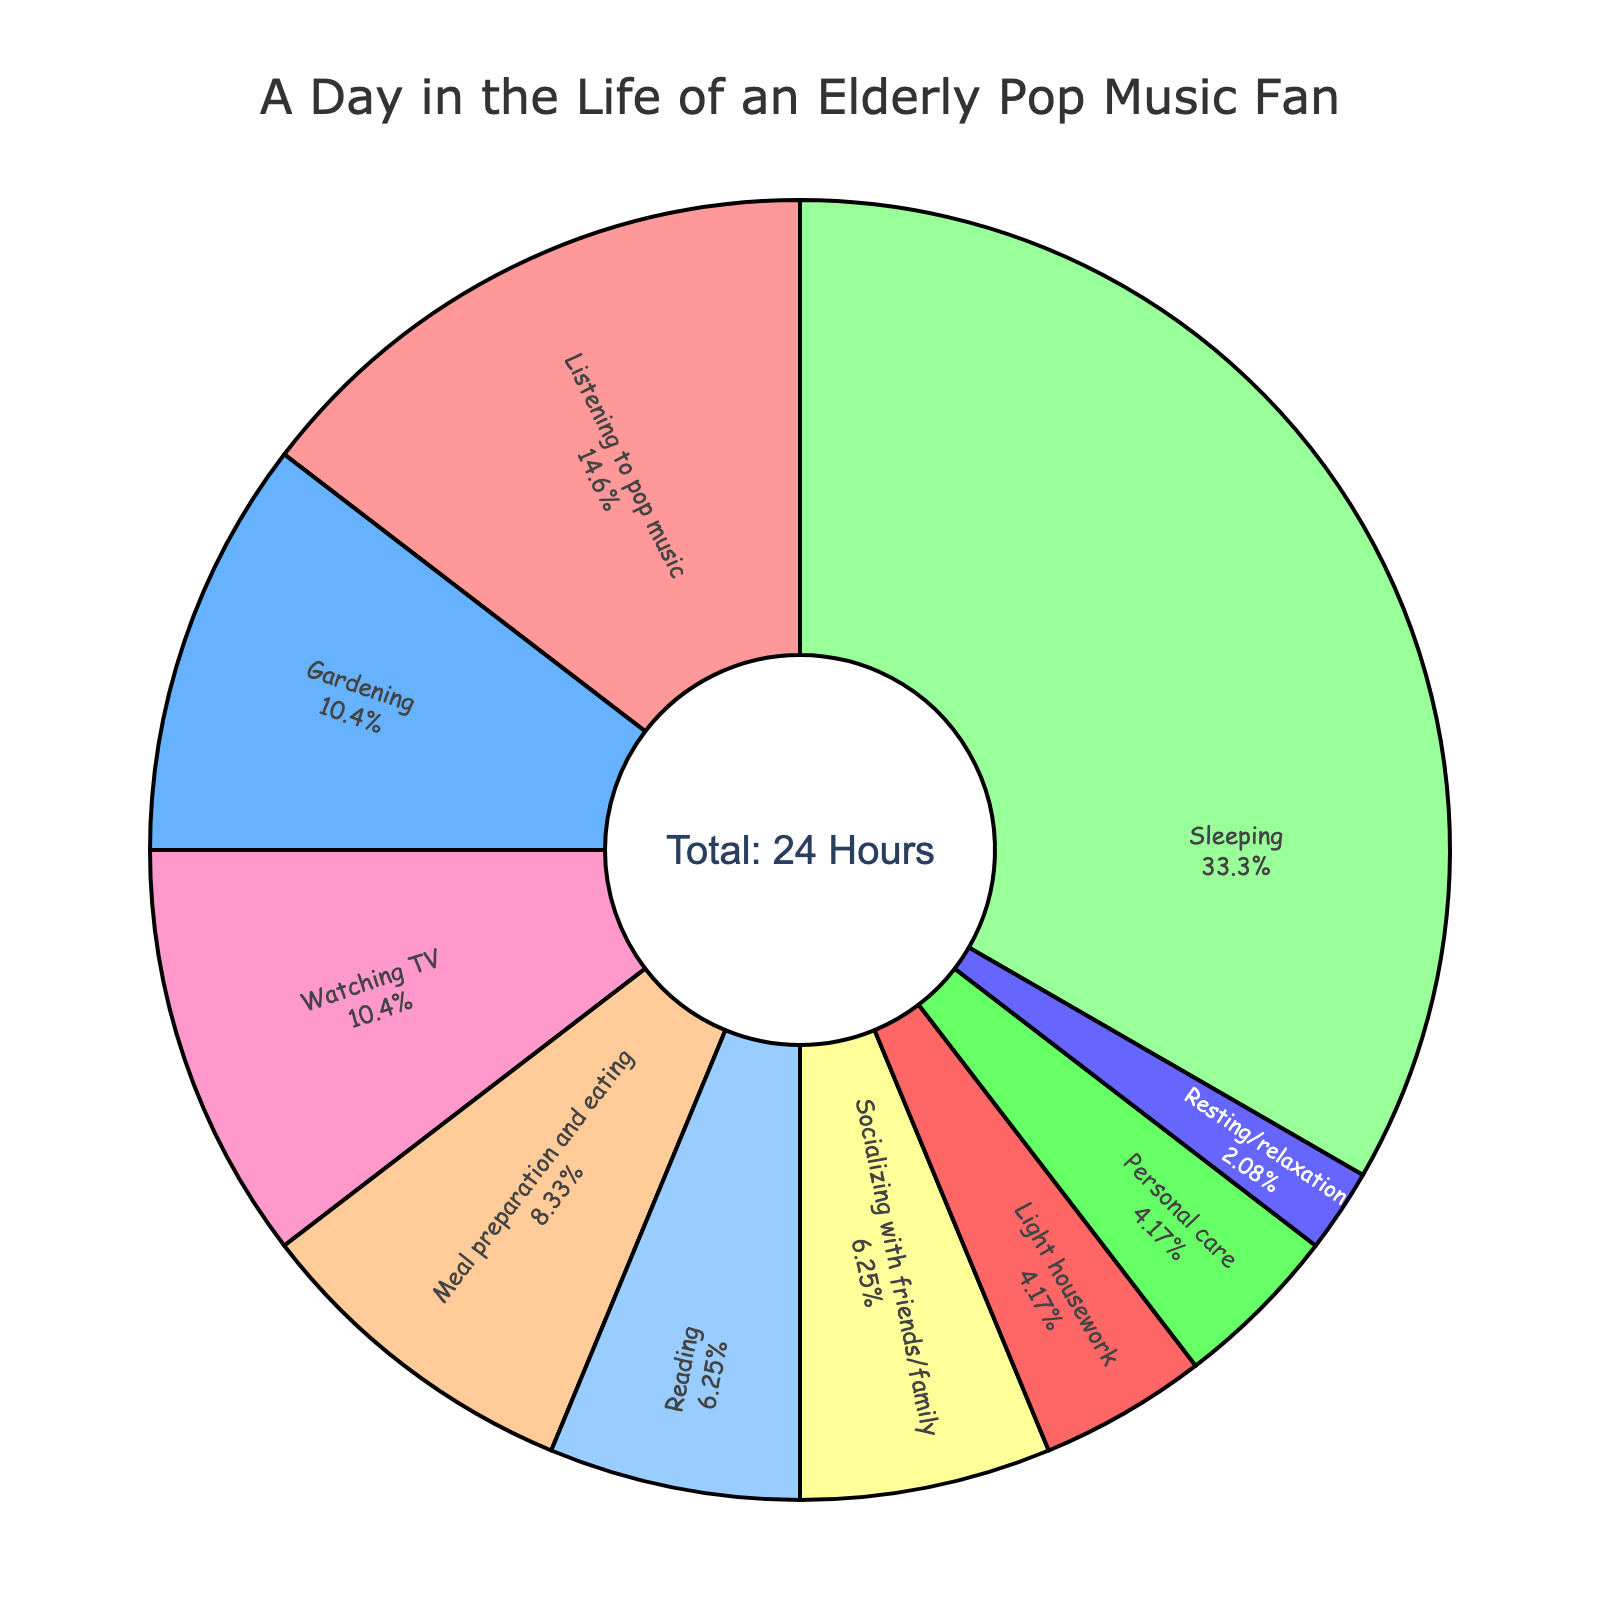What's the total time spent on activities other than sleeping? To find the total time spent on activities excluding sleeping, sum up the hours for each activity listed except for sleeping. The total will be 3.5 (Listening to pop music) + 2.5 (Gardening) + 2 (Meal preparation and eating) + 2.5 (Watching TV) + 1.5 (Reading) + 1.5 (Socializing with friends/family) + 1 (Light housework) + 1 (Personal care) + 0.5 (Resting/relaxation) = 16.5 hours
Answer: 16.5 hours Which activity occupies the most time and how much is it? Look at the pie chart to identify the activity with the largest segment. The largest segment represents the activity, which is "Sleeping" occupying 8 hours.
Answer: Sleeping, 8 hours Are more hours spent on gardening or on meal preparation and eating? By comparing the segments in the pie chart, gardening has 2.5 hours, and meal preparation and eating has 2 hours. Thus, more hours are spent on gardening.
Answer: Gardening How much more time is spent listening to pop music compared to reading? Listening to pop music takes 3.5 hours, while reading takes 1.5 hours. The difference is 3.5 - 1.5 = 2 hours.
Answer: 2 hours What's the combined time spent on watching TV and socializing with friends/family? Add the hours spent watching TV (2.5 hours) and socializing (1.5 hours). The sum is 2.5 + 1.5 = 4 hours.
Answer: 4 hours Which activity with 1 hour allocation shares color with another activity, and what are those activities? The activities with 1 hour are "Light housework" and "Personal care." These two segments share the same color shade.
Answer: Light housework and Personal care Is the time spent on resting/relaxation more, less, or equal to socializing with friends/family? Resting/relaxation is 0.5 hours, while socializing with friends/family is 1.5 hours. Therefore, resting/relaxation is less.
Answer: Less How many hours are spent on personal care and light housework combined? Both personal care and light housework each take 1 hour. The combined total is 1 + 1 = 2 hours.
Answer: 2 hours Which has a larger time allocation: meal preparation and eating, or watching TV? Watching TV has 2.5 hours and meal preparation and eating has 2 hours. Watching TV has a larger time allocation.
Answer: Watching TV What percent of the day is spent listening to pop music? Listening to pop music takes 3.5 hours out of a 24-hour day. The percentage is (3.5/24) * 100 ≈ 14.58%.
Answer: 14.58% 